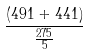Convert formula to latex. <formula><loc_0><loc_0><loc_500><loc_500>\frac { ( 4 9 1 + 4 4 1 ) } { \frac { 2 7 5 } { 5 } }</formula> 